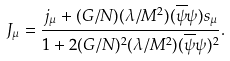<formula> <loc_0><loc_0><loc_500><loc_500>J _ { \mu } = \frac { j _ { \mu } + ( G / N ) ( \lambda / M ^ { 2 } ) ( \overline { \psi } { \psi } ) s _ { \mu } } { 1 + 2 ( G / N ) ^ { 2 } ( \lambda / M ^ { 2 } ) ( \overline { \psi } { \psi } ) ^ { 2 } } .</formula> 